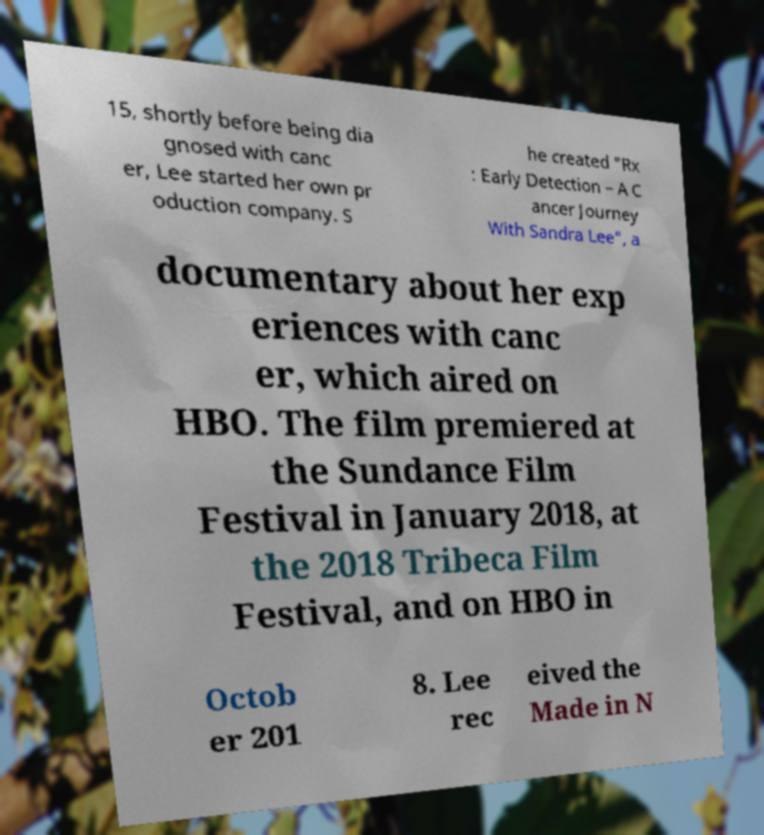There's text embedded in this image that I need extracted. Can you transcribe it verbatim? 15, shortly before being dia gnosed with canc er, Lee started her own pr oduction company. S he created "Rx : Early Detection – A C ancer Journey With Sandra Lee", a documentary about her exp eriences with canc er, which aired on HBO. The film premiered at the Sundance Film Festival in January 2018, at the 2018 Tribeca Film Festival, and on HBO in Octob er 201 8. Lee rec eived the Made in N 